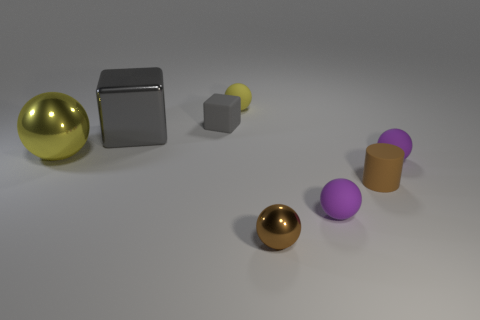What is the shape of the object that is the same color as the big metal cube?
Your answer should be very brief. Cube. Is the color of the tiny rubber sphere left of the brown shiny sphere the same as the big metallic ball?
Offer a terse response. Yes. Is the number of things that are left of the tiny metal thing greater than the number of brown matte objects?
Keep it short and to the point. Yes. There is a metal object that is behind the metallic sphere to the left of the gray block right of the big gray metal object; what is its shape?
Your response must be concise. Cube. Do the yellow metallic ball on the left side of the gray rubber block and the tiny block have the same size?
Provide a succinct answer. No. The tiny matte object that is behind the large yellow sphere and right of the small matte cube has what shape?
Ensure brevity in your answer.  Sphere. There is a large sphere; does it have the same color as the sphere behind the large block?
Offer a very short reply. Yes. There is a shiny object on the right side of the matte object on the left side of the yellow thing that is to the right of the gray shiny object; what color is it?
Provide a short and direct response. Brown. What is the color of the other large thing that is the same shape as the gray rubber thing?
Keep it short and to the point. Gray. Are there the same number of tiny purple rubber objects behind the small brown matte object and small matte cylinders?
Offer a terse response. Yes. 